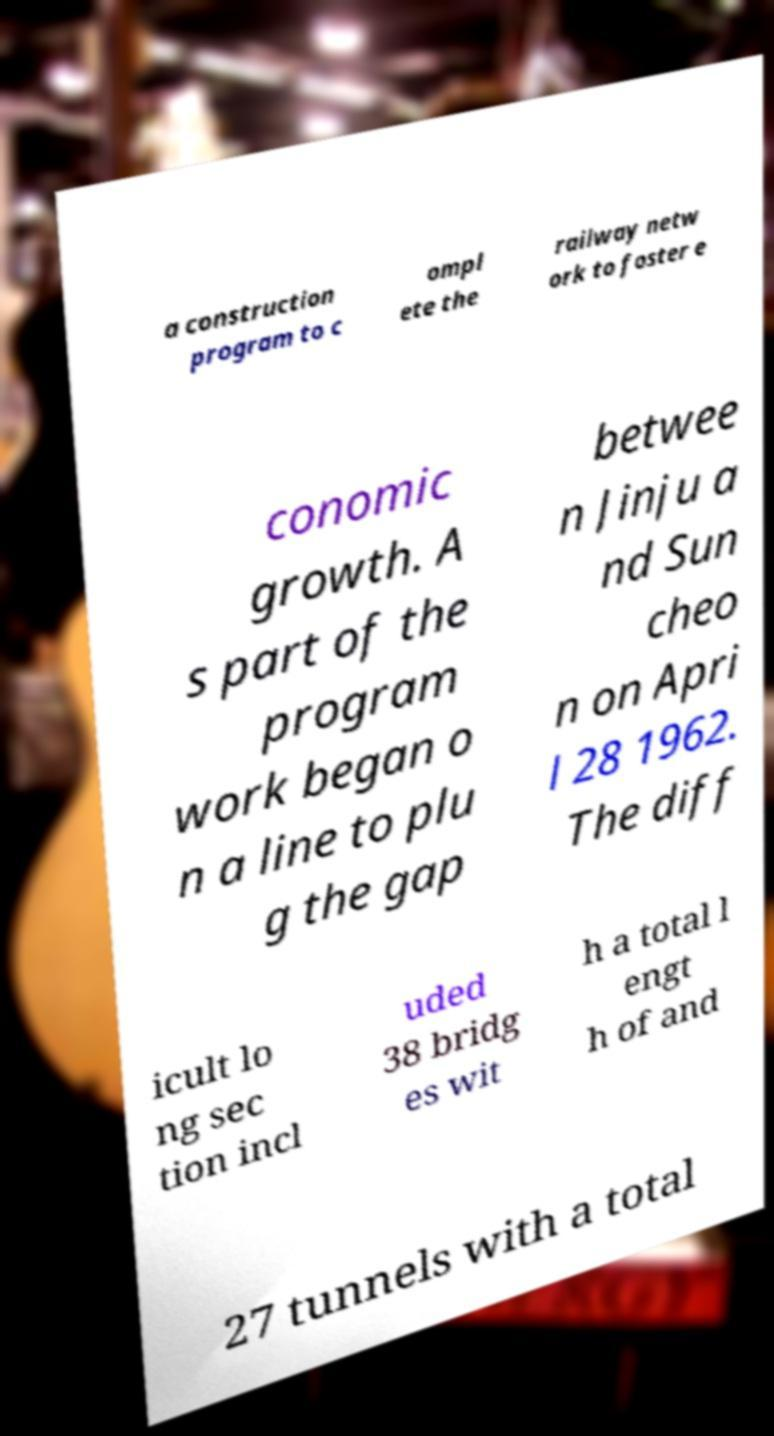What messages or text are displayed in this image? I need them in a readable, typed format. a construction program to c ompl ete the railway netw ork to foster e conomic growth. A s part of the program work began o n a line to plu g the gap betwee n Jinju a nd Sun cheo n on Apri l 28 1962. The diff icult lo ng sec tion incl uded 38 bridg es wit h a total l engt h of and 27 tunnels with a total 